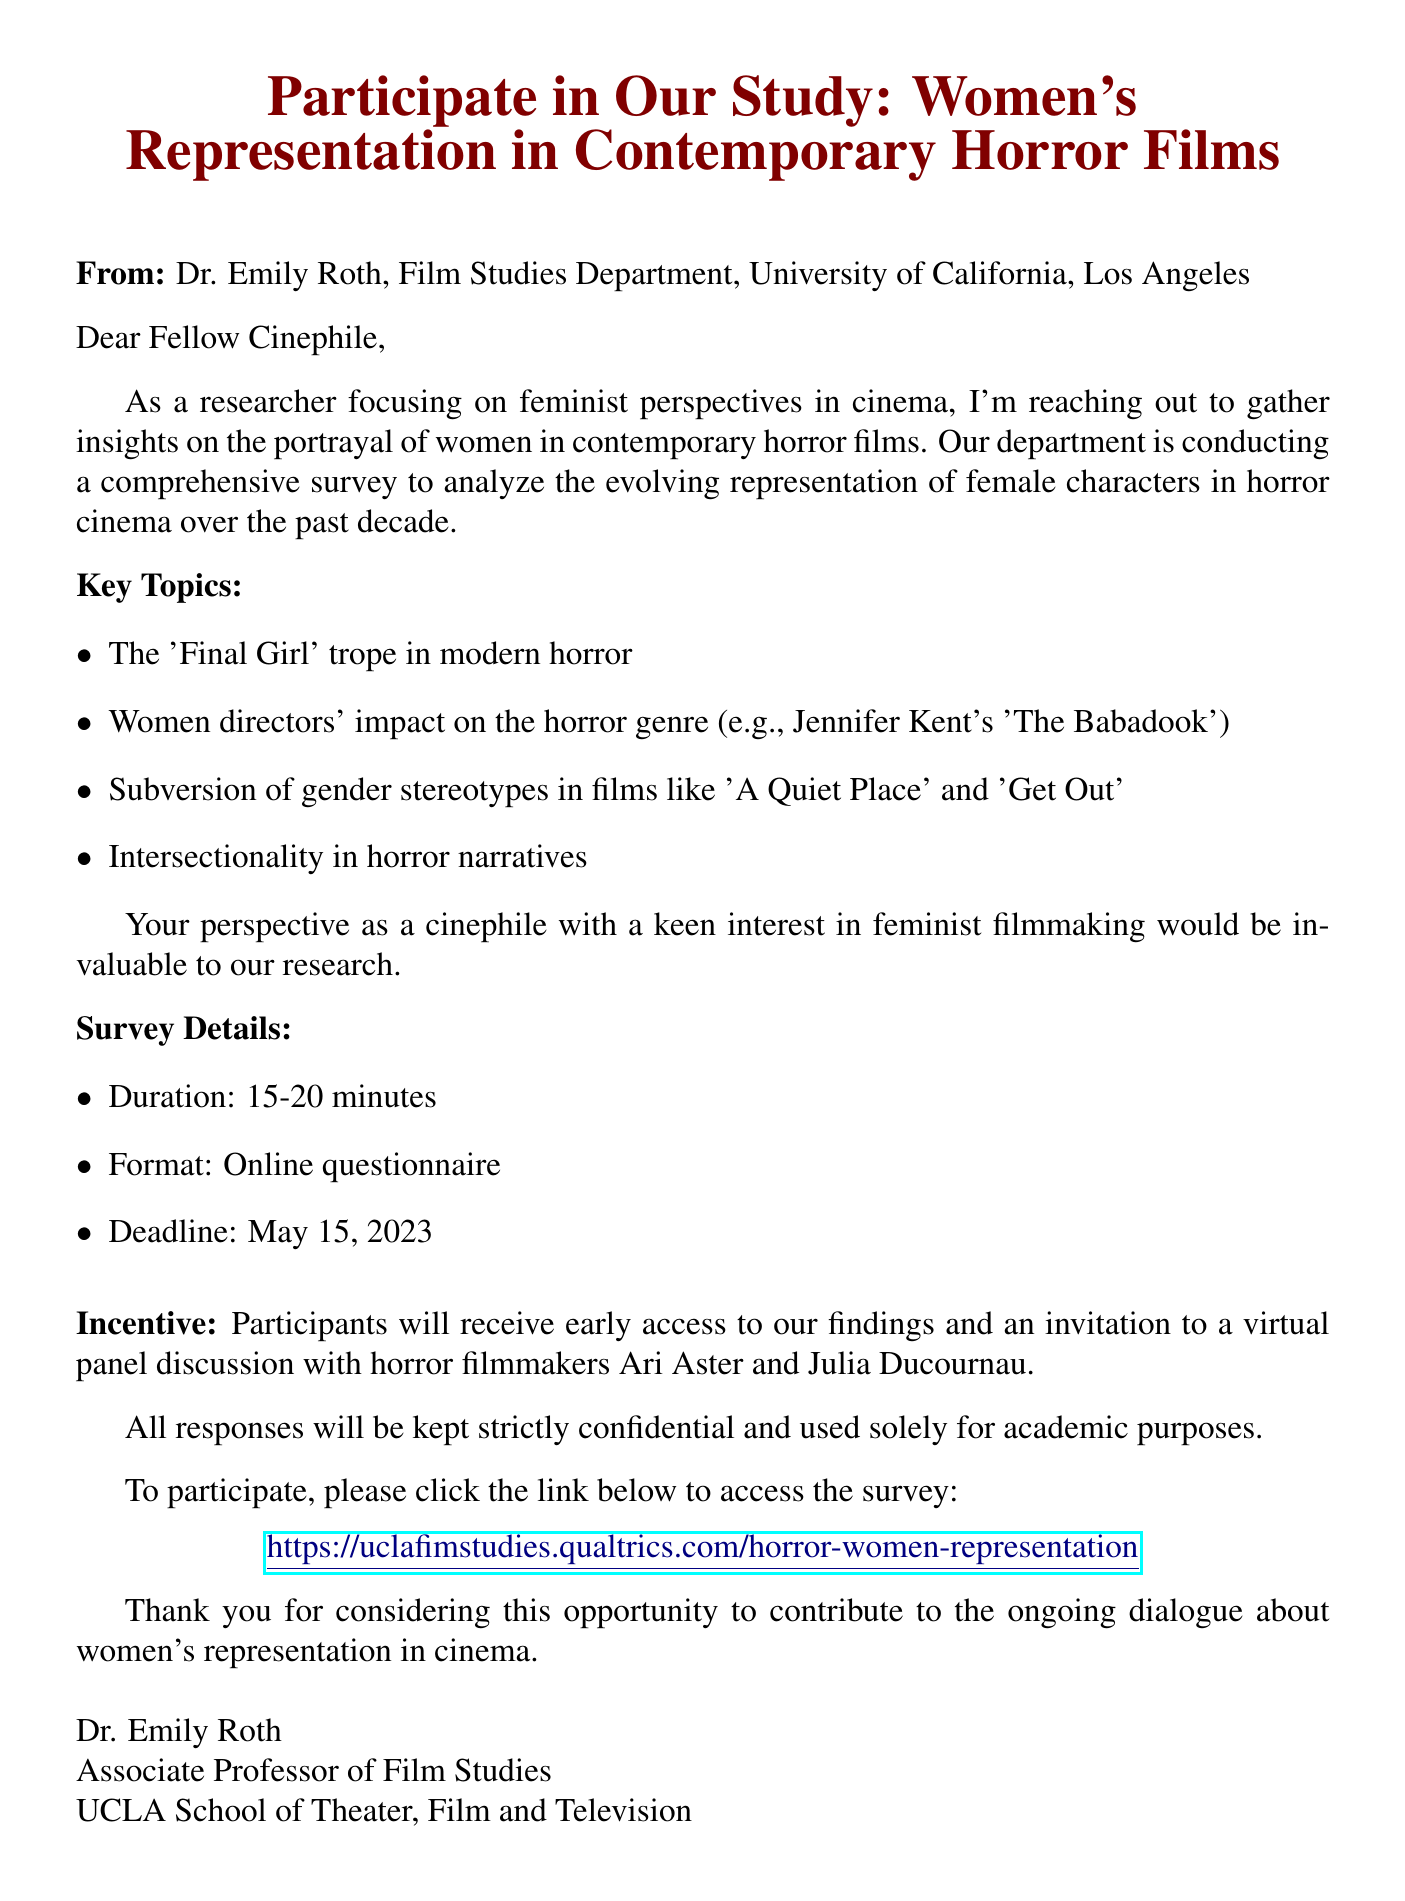What is the subject of the email? The subject of the email is stated at the beginning of the document.
Answer: Participate in Our Study: Women's Representation in Contemporary Horror Films Who is the sender of the email? The sender's name and department are provided in the opening sections of the document.
Answer: Dr. Emily Roth, Film Studies Department, University of California, Los Angeles What is the duration of the survey? The document specifies the time required to complete the survey.
Answer: 15-20 minutes What is the deadline for participating in the survey? The document mentions the last date for survey participation.
Answer: May 15, 2023 What incentive is offered to participants? The document outlines what participants will receive for completing the survey.
Answer: Early access to findings and an invitation to a virtual panel discussion What key topic related to women in horror films is mentioned? The document lists several key topics to be explored in the survey.
Answer: The 'Final Girl' trope in modern horror How is participant confidentiality assured? The document states how participants' information will be handled.
Answer: All responses will be kept strictly confidential What action is requested from the reader? The document includes a call to action for the reader to engage with the survey.
Answer: To participate, please click the link below to access the survey 